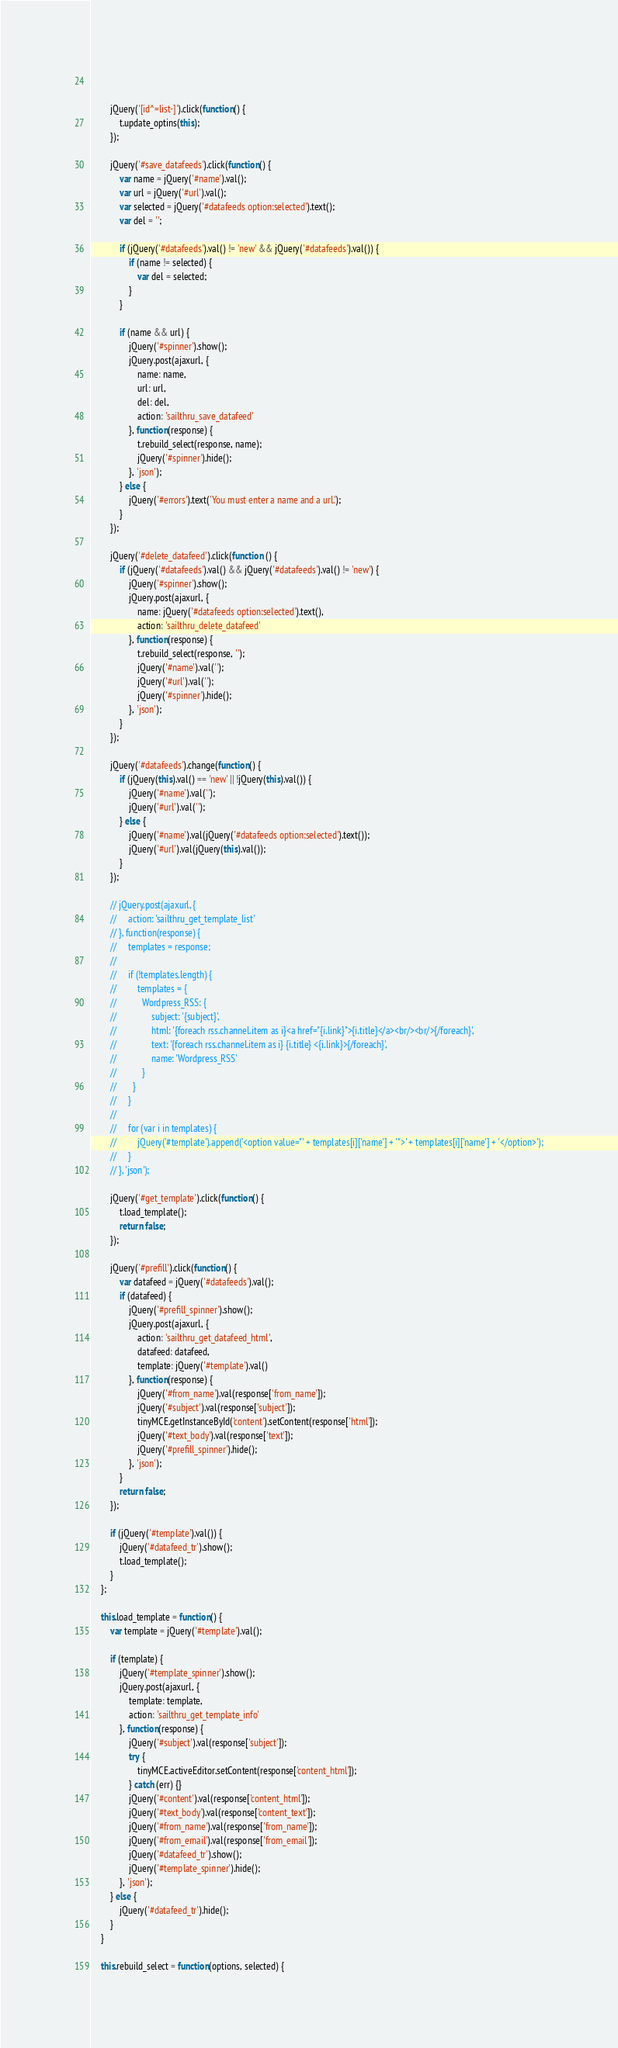Convert code to text. <code><loc_0><loc_0><loc_500><loc_500><_JavaScript_>		
		
		jQuery('[id^=list-]').click(function() {
			t.update_optins(this);
		});
		
		jQuery('#save_datafeeds').click(function() {
            var name = jQuery('#name').val();
            var url = jQuery('#url').val();
            var selected = jQuery('#datafeeds option:selected').text();
            var del = '';
            
            if (jQuery('#datafeeds').val() != 'new' && jQuery('#datafeeds').val()) {
                if (name != selected) {
                    var del = selected;
                }
            }

            if (name && url) {
                jQuery('#spinner').show();
                jQuery.post(ajaxurl, {
                    name: name, 
                    url: url, 
                    del: del, 
                    action: 'sailthru_save_datafeed'
                }, function(response) {
                    t.rebuild_select(response, name);
                    jQuery('#spinner').hide();
                }, 'json');
            } else {
                jQuery('#errors').text('You must enter a name and a url.');
            }
	    });
	    
	    jQuery('#delete_datafeed').click(function () {
	        if (jQuery('#datafeeds').val() && jQuery('#datafeeds').val() != 'new') {
    	        jQuery('#spinner').show();
    	        jQuery.post(ajaxurl, {
    	            name: jQuery('#datafeeds option:selected').text(), 
    	            action: 'sailthru_delete_datafeed'
                }, function(response) {
                    t.rebuild_select(response, '');
                    jQuery('#name').val('');
    	            jQuery('#url').val('');
                    jQuery('#spinner').hide();
                }, 'json');
            }
        });
	    
	    jQuery('#datafeeds').change(function() {
	        if (jQuery(this).val() == 'new' || !jQuery(this).val()) {
	            jQuery('#name').val('');
	            jQuery('#url').val('');
            } else {
                jQuery('#name').val(jQuery('#datafeeds option:selected').text());
                jQuery('#url').val(jQuery(this).val());
            }
        });

        // jQuery.post(ajaxurl, {
        //     action: 'sailthru_get_template_list'
        // }, function(response) {
        //     templates = response;
        // 
        //     if (!templates.length) {
        //         templates = {
        //           Wordpress_RSS: {
        //               subject: '{subject}', 
        //               html: '{foreach rss.channel.item as i}<a href="{i.link}">{i.title}</a><br/><br/>{/foreach}', 
        //               text: '{foreach rss.channel.item as i} {i.title} <{i.link}>{/foreach}', 
        //               name: 'Wordpress_RSS'
        //           }
        //       }
        //     }
        // 
        //     for (var i in templates) {
        //         jQuery('#template').append('<option value="' + templates[i]['name'] + '">' + templates[i]['name'] + '</option>');
        //     }
        // }, 'json');

        jQuery('#get_template').click(function() {
            t.load_template();
            return false;
        });
        
        jQuery('#prefill').click(function() {
            var datafeed = jQuery('#datafeeds').val();
            if (datafeed) {
                jQuery('#prefill_spinner').show();
                jQuery.post(ajaxurl, {
                    action: 'sailthru_get_datafeed_html', 
                    datafeed: datafeed, 
                    template: jQuery('#template').val()
                }, function(response) {
                    jQuery('#from_name').val(response['from_name']);
                    jQuery('#subject').val(response['subject']);
                    tinyMCE.getInstanceById('content').setContent(response['html']);
                    jQuery('#text_body').val(response['text']);
                    jQuery('#prefill_spinner').hide();
                }, 'json');
            }
            return false;
        });
        
        if (jQuery('#template').val()) {
            jQuery('#datafeed_tr').show();
            t.load_template();
        }
	};
	
	this.load_template = function() {
	    var template = jQuery('#template').val();

        if (template) {
            jQuery('#template_spinner').show();
            jQuery.post(ajaxurl, {
                template: template, 
                action: 'sailthru_get_template_info'
            }, function(response) {
                jQuery('#subject').val(response['subject']);
                try {
                    tinyMCE.activeEditor.setContent(response['content_html']);
                } catch (err) {}
                jQuery('#content').val(response['content_html']);
                jQuery('#text_body').val(response['content_text']);
                jQuery('#from_name').val(response['from_name']);
                jQuery('#from_email').val(response['from_email']);
                jQuery('#datafeed_tr').show();
                jQuery('#template_spinner').hide();
            }, 'json');
        } else {
            jQuery('#datafeed_tr').hide();
        }
    }
	
	this.rebuild_select = function(options, selected) {</code> 